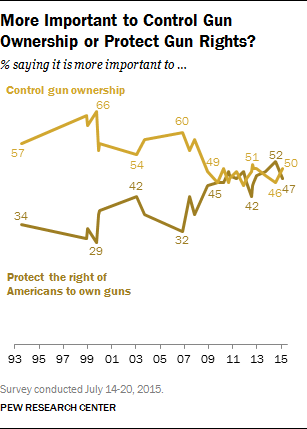What's the rightmost value on the dark brown graph? The rightmost value on the dark brown graph, which represents the percentage of people who say it's more important to control gun ownership, is 50 for the year 2015. This is part of a survey conducted by the Pew Research Center over the years, showing public opinion changes over time. 